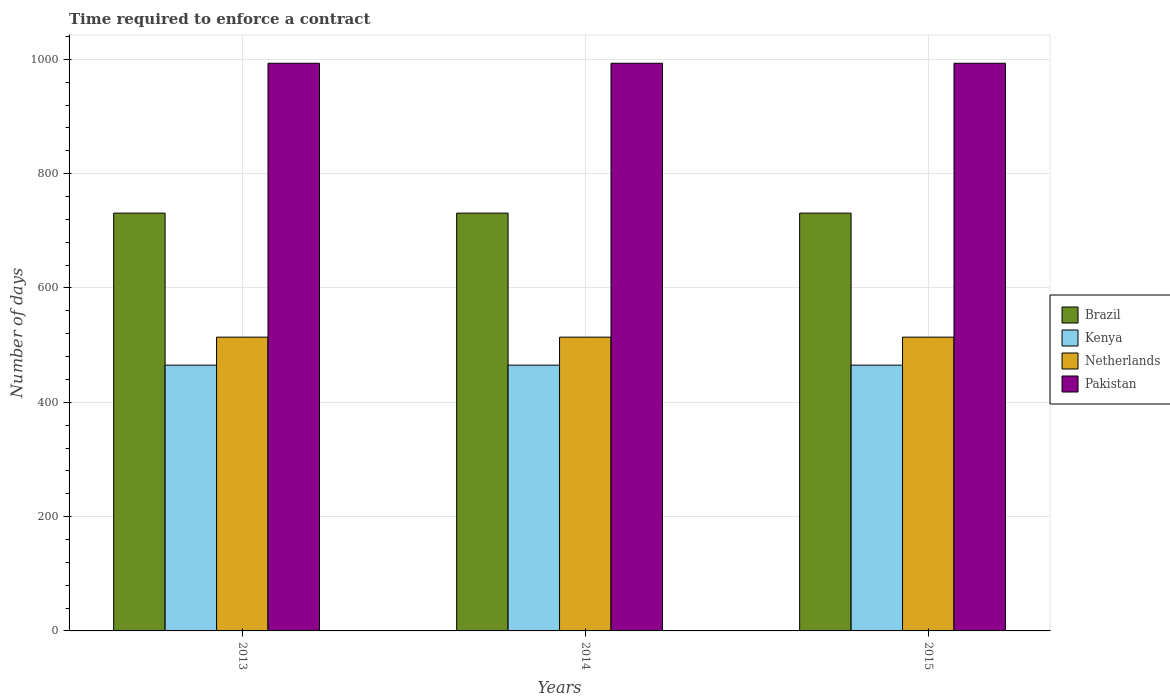How many groups of bars are there?
Your answer should be compact. 3. Are the number of bars per tick equal to the number of legend labels?
Provide a short and direct response. Yes. Are the number of bars on each tick of the X-axis equal?
Your response must be concise. Yes. How many bars are there on the 2nd tick from the left?
Your answer should be very brief. 4. How many bars are there on the 1st tick from the right?
Give a very brief answer. 4. In how many cases, is the number of bars for a given year not equal to the number of legend labels?
Your answer should be compact. 0. What is the number of days required to enforce a contract in Pakistan in 2015?
Provide a succinct answer. 993.2. Across all years, what is the maximum number of days required to enforce a contract in Brazil?
Your answer should be compact. 731. Across all years, what is the minimum number of days required to enforce a contract in Kenya?
Give a very brief answer. 465. In which year was the number of days required to enforce a contract in Pakistan minimum?
Offer a terse response. 2013. What is the total number of days required to enforce a contract in Brazil in the graph?
Your answer should be compact. 2193. What is the difference between the number of days required to enforce a contract in Brazil in 2014 and that in 2015?
Keep it short and to the point. 0. What is the difference between the number of days required to enforce a contract in Pakistan in 2014 and the number of days required to enforce a contract in Kenya in 2013?
Your response must be concise. 528.2. What is the average number of days required to enforce a contract in Brazil per year?
Give a very brief answer. 731. In the year 2013, what is the difference between the number of days required to enforce a contract in Kenya and number of days required to enforce a contract in Netherlands?
Provide a short and direct response. -49. What is the ratio of the number of days required to enforce a contract in Netherlands in 2013 to that in 2015?
Your answer should be compact. 1. What is the difference between the highest and the second highest number of days required to enforce a contract in Kenya?
Make the answer very short. 0. Is the sum of the number of days required to enforce a contract in Brazil in 2014 and 2015 greater than the maximum number of days required to enforce a contract in Pakistan across all years?
Ensure brevity in your answer.  Yes. What does the 2nd bar from the left in 2013 represents?
Your answer should be compact. Kenya. What does the 3rd bar from the right in 2013 represents?
Your answer should be very brief. Kenya. Are all the bars in the graph horizontal?
Ensure brevity in your answer.  No. Are the values on the major ticks of Y-axis written in scientific E-notation?
Provide a succinct answer. No. Does the graph contain grids?
Offer a very short reply. Yes. Where does the legend appear in the graph?
Your response must be concise. Center right. How are the legend labels stacked?
Keep it short and to the point. Vertical. What is the title of the graph?
Offer a very short reply. Time required to enforce a contract. What is the label or title of the Y-axis?
Provide a short and direct response. Number of days. What is the Number of days of Brazil in 2013?
Offer a terse response. 731. What is the Number of days in Kenya in 2013?
Offer a terse response. 465. What is the Number of days in Netherlands in 2013?
Provide a succinct answer. 514. What is the Number of days in Pakistan in 2013?
Give a very brief answer. 993.2. What is the Number of days of Brazil in 2014?
Offer a terse response. 731. What is the Number of days of Kenya in 2014?
Provide a succinct answer. 465. What is the Number of days of Netherlands in 2014?
Keep it short and to the point. 514. What is the Number of days in Pakistan in 2014?
Ensure brevity in your answer.  993.2. What is the Number of days in Brazil in 2015?
Your answer should be compact. 731. What is the Number of days of Kenya in 2015?
Provide a succinct answer. 465. What is the Number of days of Netherlands in 2015?
Your answer should be very brief. 514. What is the Number of days of Pakistan in 2015?
Your answer should be very brief. 993.2. Across all years, what is the maximum Number of days of Brazil?
Your answer should be compact. 731. Across all years, what is the maximum Number of days of Kenya?
Your response must be concise. 465. Across all years, what is the maximum Number of days of Netherlands?
Your answer should be very brief. 514. Across all years, what is the maximum Number of days in Pakistan?
Make the answer very short. 993.2. Across all years, what is the minimum Number of days in Brazil?
Make the answer very short. 731. Across all years, what is the minimum Number of days in Kenya?
Your response must be concise. 465. Across all years, what is the minimum Number of days in Netherlands?
Keep it short and to the point. 514. Across all years, what is the minimum Number of days of Pakistan?
Give a very brief answer. 993.2. What is the total Number of days of Brazil in the graph?
Make the answer very short. 2193. What is the total Number of days in Kenya in the graph?
Your answer should be compact. 1395. What is the total Number of days of Netherlands in the graph?
Give a very brief answer. 1542. What is the total Number of days of Pakistan in the graph?
Provide a succinct answer. 2979.6. What is the difference between the Number of days of Brazil in 2013 and that in 2014?
Give a very brief answer. 0. What is the difference between the Number of days of Pakistan in 2013 and that in 2014?
Provide a succinct answer. 0. What is the difference between the Number of days in Brazil in 2013 and that in 2015?
Your answer should be very brief. 0. What is the difference between the Number of days of Kenya in 2013 and that in 2015?
Ensure brevity in your answer.  0. What is the difference between the Number of days of Pakistan in 2013 and that in 2015?
Keep it short and to the point. 0. What is the difference between the Number of days in Brazil in 2013 and the Number of days in Kenya in 2014?
Provide a succinct answer. 266. What is the difference between the Number of days in Brazil in 2013 and the Number of days in Netherlands in 2014?
Provide a succinct answer. 217. What is the difference between the Number of days in Brazil in 2013 and the Number of days in Pakistan in 2014?
Keep it short and to the point. -262.2. What is the difference between the Number of days of Kenya in 2013 and the Number of days of Netherlands in 2014?
Your response must be concise. -49. What is the difference between the Number of days in Kenya in 2013 and the Number of days in Pakistan in 2014?
Ensure brevity in your answer.  -528.2. What is the difference between the Number of days of Netherlands in 2013 and the Number of days of Pakistan in 2014?
Offer a very short reply. -479.2. What is the difference between the Number of days of Brazil in 2013 and the Number of days of Kenya in 2015?
Provide a succinct answer. 266. What is the difference between the Number of days of Brazil in 2013 and the Number of days of Netherlands in 2015?
Give a very brief answer. 217. What is the difference between the Number of days in Brazil in 2013 and the Number of days in Pakistan in 2015?
Offer a very short reply. -262.2. What is the difference between the Number of days in Kenya in 2013 and the Number of days in Netherlands in 2015?
Your response must be concise. -49. What is the difference between the Number of days in Kenya in 2013 and the Number of days in Pakistan in 2015?
Make the answer very short. -528.2. What is the difference between the Number of days in Netherlands in 2013 and the Number of days in Pakistan in 2015?
Provide a short and direct response. -479.2. What is the difference between the Number of days of Brazil in 2014 and the Number of days of Kenya in 2015?
Keep it short and to the point. 266. What is the difference between the Number of days of Brazil in 2014 and the Number of days of Netherlands in 2015?
Provide a short and direct response. 217. What is the difference between the Number of days in Brazil in 2014 and the Number of days in Pakistan in 2015?
Ensure brevity in your answer.  -262.2. What is the difference between the Number of days in Kenya in 2014 and the Number of days in Netherlands in 2015?
Make the answer very short. -49. What is the difference between the Number of days in Kenya in 2014 and the Number of days in Pakistan in 2015?
Provide a succinct answer. -528.2. What is the difference between the Number of days of Netherlands in 2014 and the Number of days of Pakistan in 2015?
Your response must be concise. -479.2. What is the average Number of days in Brazil per year?
Your answer should be very brief. 731. What is the average Number of days in Kenya per year?
Ensure brevity in your answer.  465. What is the average Number of days of Netherlands per year?
Ensure brevity in your answer.  514. What is the average Number of days in Pakistan per year?
Provide a short and direct response. 993.2. In the year 2013, what is the difference between the Number of days of Brazil and Number of days of Kenya?
Make the answer very short. 266. In the year 2013, what is the difference between the Number of days in Brazil and Number of days in Netherlands?
Give a very brief answer. 217. In the year 2013, what is the difference between the Number of days in Brazil and Number of days in Pakistan?
Offer a terse response. -262.2. In the year 2013, what is the difference between the Number of days in Kenya and Number of days in Netherlands?
Offer a very short reply. -49. In the year 2013, what is the difference between the Number of days in Kenya and Number of days in Pakistan?
Keep it short and to the point. -528.2. In the year 2013, what is the difference between the Number of days in Netherlands and Number of days in Pakistan?
Provide a short and direct response. -479.2. In the year 2014, what is the difference between the Number of days in Brazil and Number of days in Kenya?
Offer a terse response. 266. In the year 2014, what is the difference between the Number of days in Brazil and Number of days in Netherlands?
Your response must be concise. 217. In the year 2014, what is the difference between the Number of days in Brazil and Number of days in Pakistan?
Your response must be concise. -262.2. In the year 2014, what is the difference between the Number of days in Kenya and Number of days in Netherlands?
Ensure brevity in your answer.  -49. In the year 2014, what is the difference between the Number of days of Kenya and Number of days of Pakistan?
Keep it short and to the point. -528.2. In the year 2014, what is the difference between the Number of days of Netherlands and Number of days of Pakistan?
Make the answer very short. -479.2. In the year 2015, what is the difference between the Number of days in Brazil and Number of days in Kenya?
Make the answer very short. 266. In the year 2015, what is the difference between the Number of days in Brazil and Number of days in Netherlands?
Offer a terse response. 217. In the year 2015, what is the difference between the Number of days in Brazil and Number of days in Pakistan?
Ensure brevity in your answer.  -262.2. In the year 2015, what is the difference between the Number of days of Kenya and Number of days of Netherlands?
Provide a succinct answer. -49. In the year 2015, what is the difference between the Number of days in Kenya and Number of days in Pakistan?
Give a very brief answer. -528.2. In the year 2015, what is the difference between the Number of days in Netherlands and Number of days in Pakistan?
Your response must be concise. -479.2. What is the ratio of the Number of days in Kenya in 2013 to that in 2014?
Your answer should be very brief. 1. What is the ratio of the Number of days in Brazil in 2013 to that in 2015?
Offer a very short reply. 1. What is the ratio of the Number of days in Pakistan in 2013 to that in 2015?
Offer a very short reply. 1. What is the ratio of the Number of days of Kenya in 2014 to that in 2015?
Provide a succinct answer. 1. What is the ratio of the Number of days of Netherlands in 2014 to that in 2015?
Offer a very short reply. 1. What is the difference between the highest and the second highest Number of days of Brazil?
Your answer should be very brief. 0. What is the difference between the highest and the second highest Number of days in Kenya?
Provide a short and direct response. 0. What is the difference between the highest and the second highest Number of days in Pakistan?
Ensure brevity in your answer.  0. What is the difference between the highest and the lowest Number of days in Brazil?
Ensure brevity in your answer.  0. What is the difference between the highest and the lowest Number of days of Netherlands?
Keep it short and to the point. 0. 